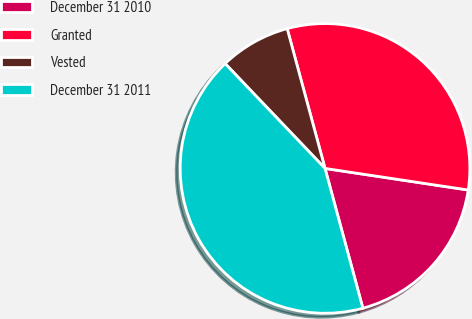<chart> <loc_0><loc_0><loc_500><loc_500><pie_chart><fcel>December 31 2010<fcel>Granted<fcel>Vested<fcel>December 31 2011<nl><fcel>18.41%<fcel>31.59%<fcel>7.91%<fcel>42.09%<nl></chart> 